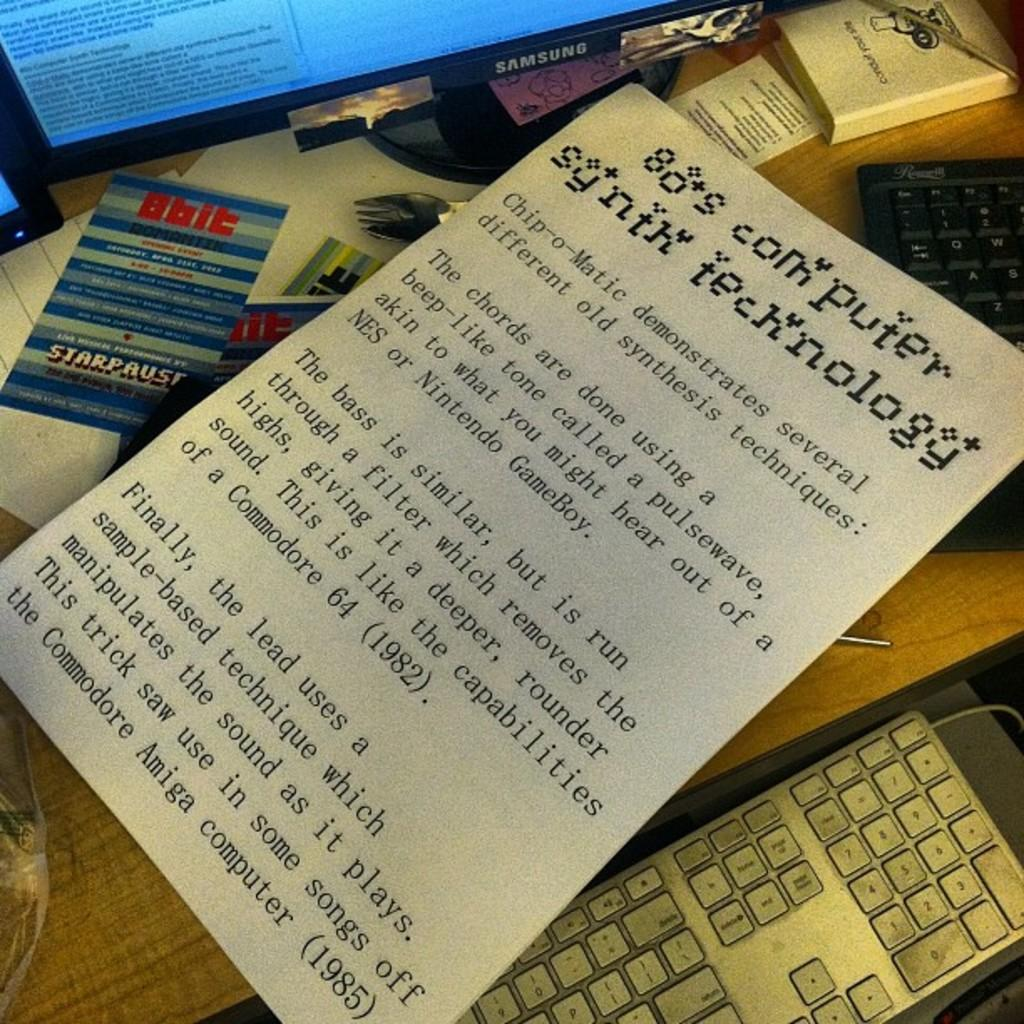<image>
Offer a succinct explanation of the picture presented. A paper on top of a keyboard with the words 80's computer synth technology on it. 